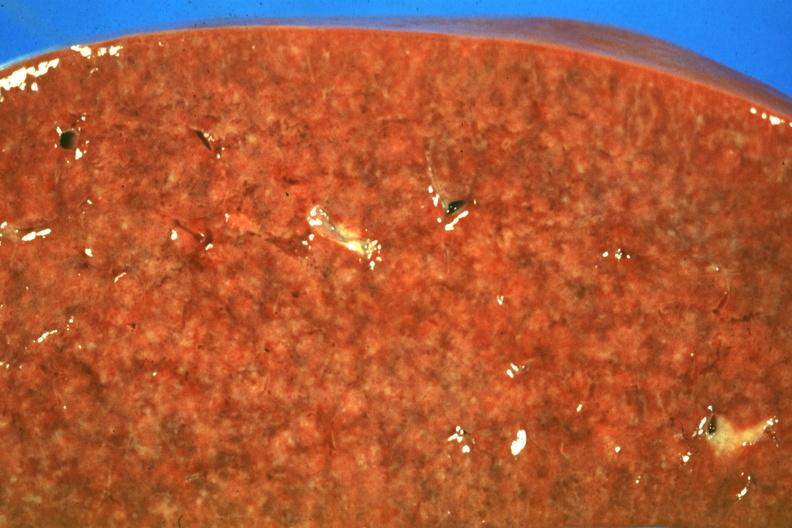what is present?
Answer the question using a single word or phrase. Spleen 